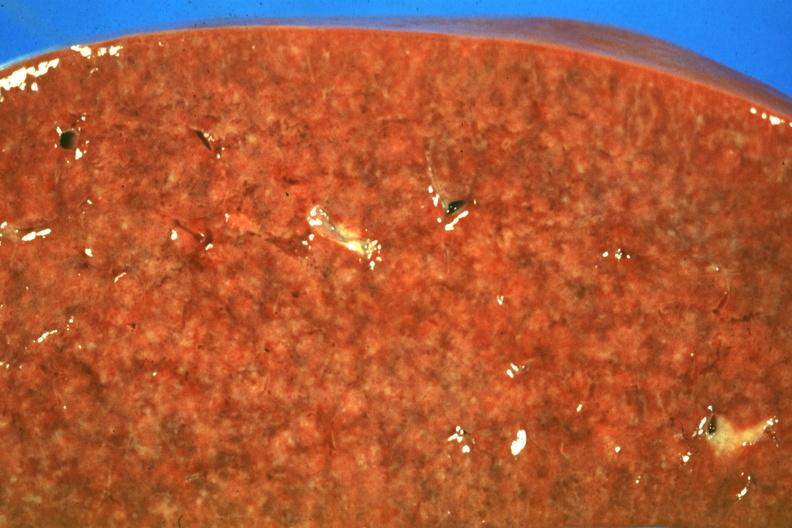what is present?
Answer the question using a single word or phrase. Spleen 